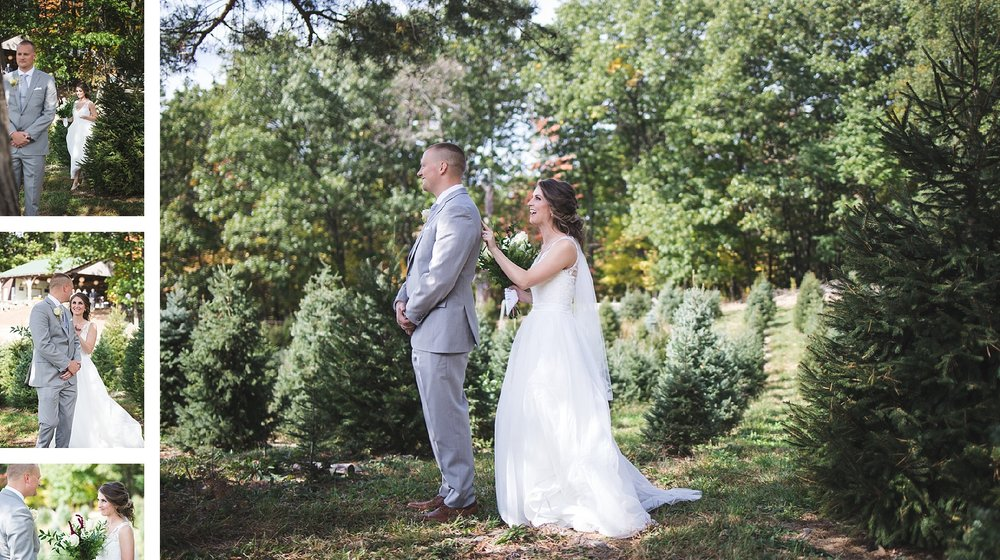What does the body language of the individuals in the image suggest about their feelings on this occasion? The individuals in the image exhibit body language that speaks to a moment of joyful anticipation and affection. The bride's beaming smile and relaxed posture as she holds her bouquet suggest a feeling of happiness and contentment. The groom stands upright with a composed demeanor, looking at the bride with a soft expression, which may indicate feelings of love and pride. Their shared body language reflects a comfortable bond and a shared sense of excitement for the future they are about to embark on together. 